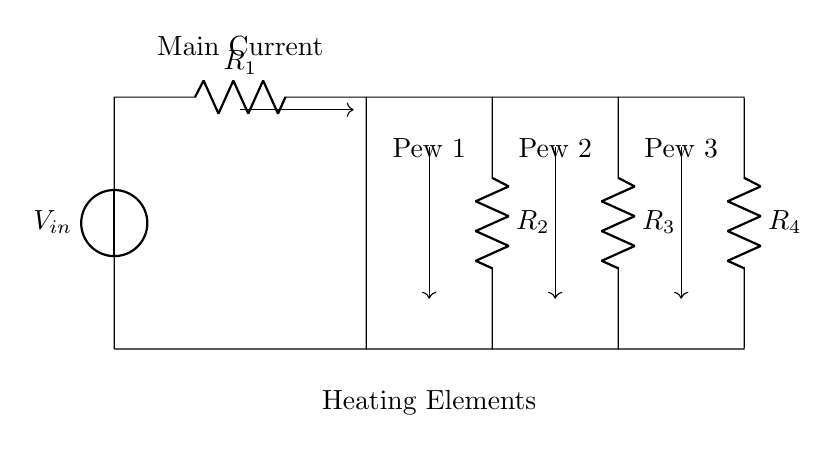What is the input voltage in this circuit? The input voltage, labeled as V in the diagram, is indicated near the voltage source at the top of the circuit.
Answer: V How many resistors are in the current divider circuit? The circuit diagram clearly shows four resistors connected in parallel, as they are all linked to the same two nodes at the top and bottom.
Answer: Four Which heating element corresponds to resistor R2? Resistor R2 is the second resistor from the left, and the circuit labels it to correspond to Pew 1, which indicates its connection to the heating element designated for that pew.
Answer: Pew 1 What happens to current distribution if R3 is reduced? Reducing the resistance of R3 causes an increase in the current flowing through it, following the current divider rule, which states that current divides inversely with resistance.
Answer: Increase What is the equivalent resistance of the current divider? The equivalent resistance can be calculated by using the formula for resistors in parallel, which is one over the sum of the reciprocals of each resistor's resistance. Since the values of R1, R2, R3, and R4 are not given, the exact value cannot be computed; however, it can be approximated if resistance values are known.
Answer: Not computable without values Which pew's heating element receives the most current if all resistors are equal? If all resistors are of equal value, the current will be distributed evenly among the three heating elements since they share the same electrical potential and resistive value, resulting in equal current outputs to each.
Answer: All equal What is the main function of this circuit? The circuit's primary function is to distribute the power from the voltage source evenly across the four resistors, supplying current to the heating elements connected to each pew in the church.
Answer: Distribute power 